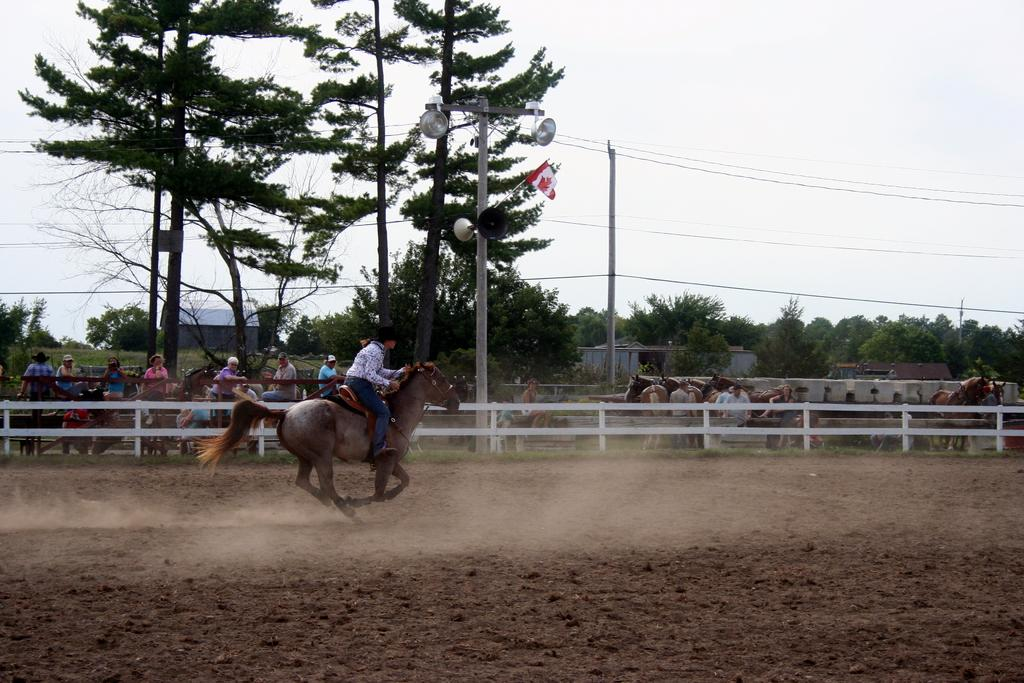What is the main subject of the image? There is a person riding a horse in the image. What can be seen beneath the horse and rider? The ground is visible in the image. What is present in the background of the image? There is a fence, people, horses, trees, sheds, poles, and the sky visible in the background of the image. Can you describe the objects in the background? There are some objects in the background of the image, but their specific nature is not clear from the provided facts. What type of trade is being conducted between the person and the horse in the image? There is no indication of any trade being conducted between the person and the horse in the image. What hope does the person riding the horse have for the future? The image does not provide any information about the person's hopes or aspirations for the future. 